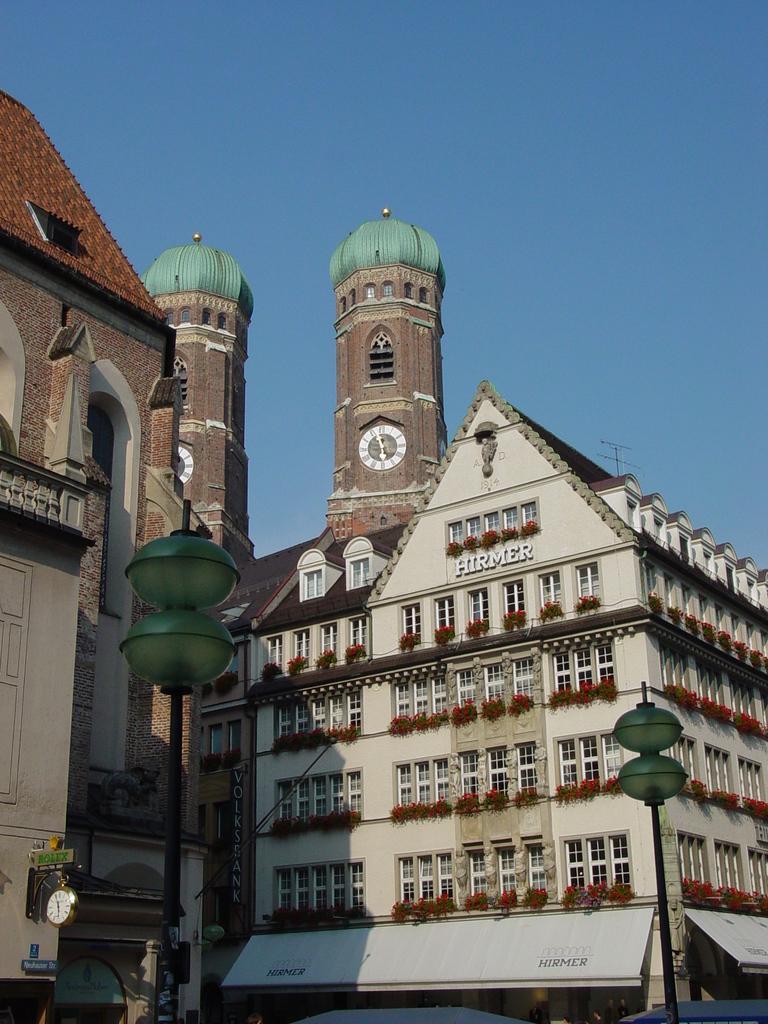How would you summarize this image in a sentence or two? In the center of the image there are buildings. At the bottom there are poles. In the background there is sky. 